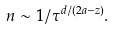Convert formula to latex. <formula><loc_0><loc_0><loc_500><loc_500>n \sim 1 / \tau ^ { d / ( 2 a - z ) } .</formula> 